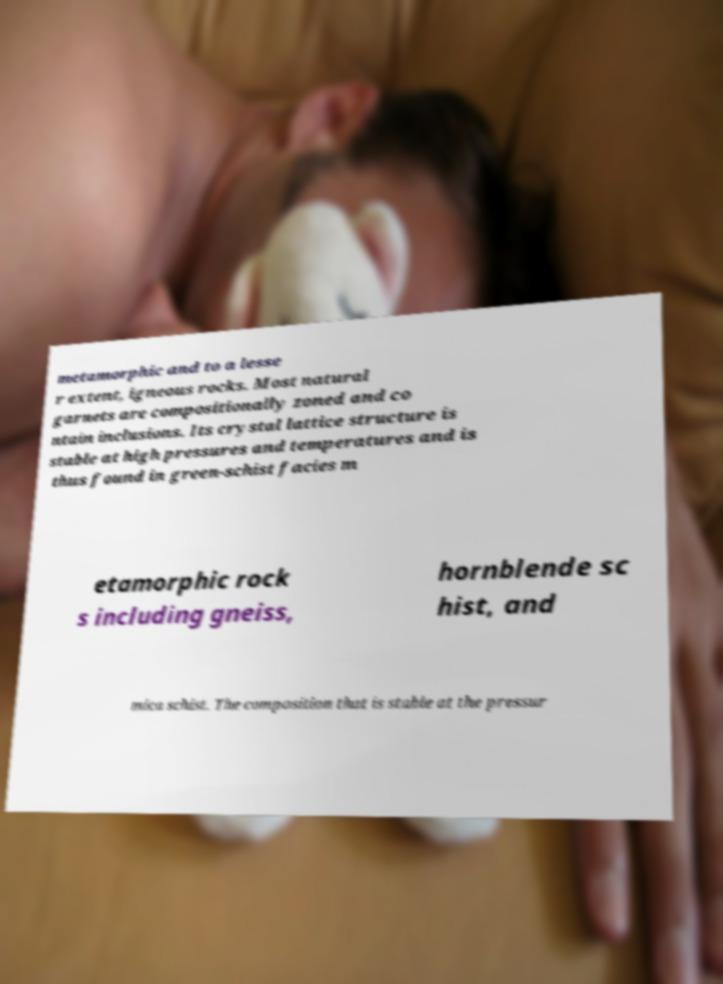There's text embedded in this image that I need extracted. Can you transcribe it verbatim? metamorphic and to a lesse r extent, igneous rocks. Most natural garnets are compositionally zoned and co ntain inclusions. Its crystal lattice structure is stable at high pressures and temperatures and is thus found in green-schist facies m etamorphic rock s including gneiss, hornblende sc hist, and mica schist. The composition that is stable at the pressur 